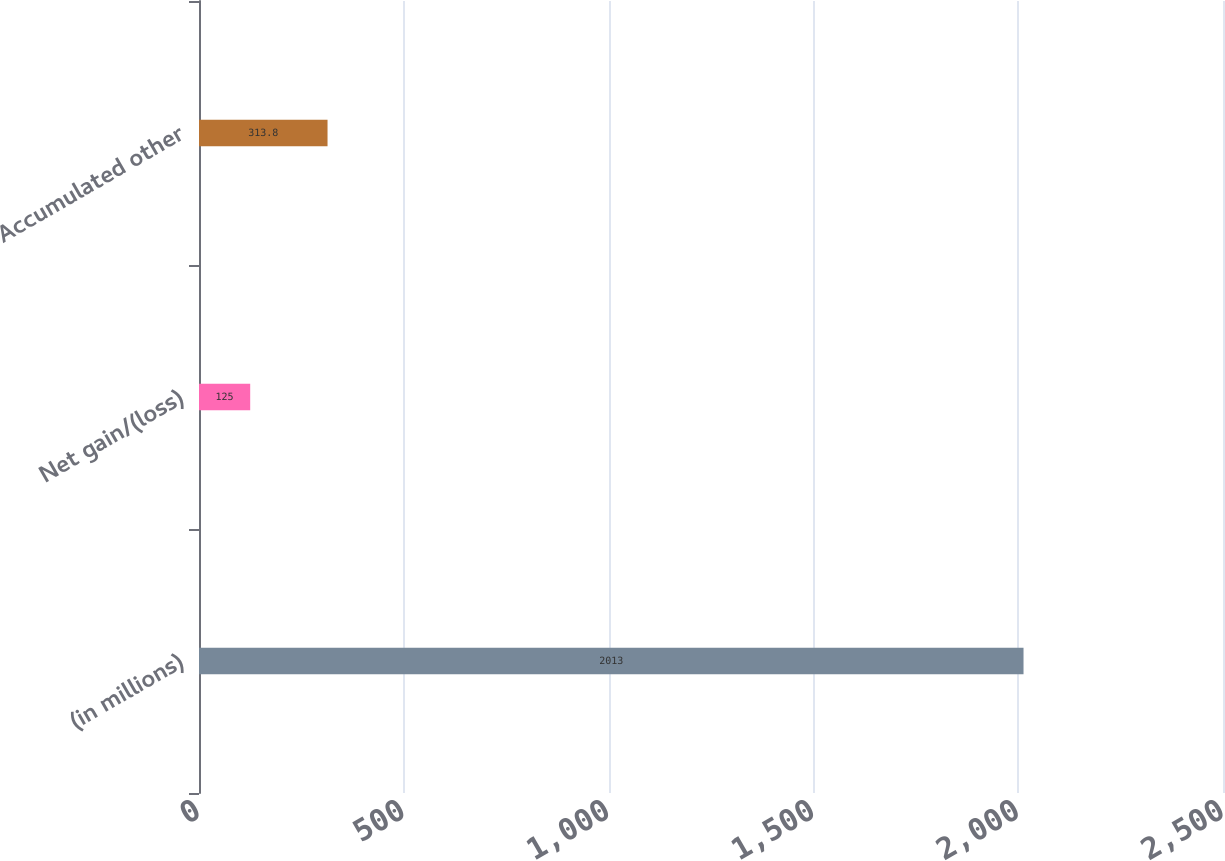Convert chart. <chart><loc_0><loc_0><loc_500><loc_500><bar_chart><fcel>(in millions)<fcel>Net gain/(loss)<fcel>Accumulated other<nl><fcel>2013<fcel>125<fcel>313.8<nl></chart> 